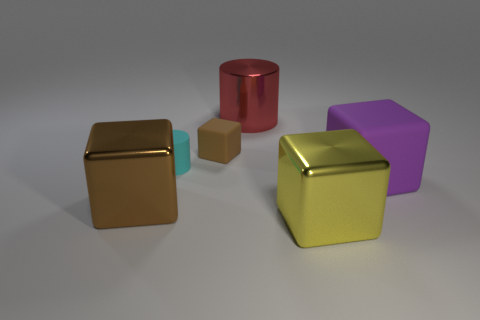Is there a metallic thing that has the same color as the small rubber block?
Give a very brief answer. Yes. There is a rubber cube behind the purple block; is its size the same as the yellow metal block?
Provide a succinct answer. No. What number of matte objects are either large yellow cubes or tiny gray objects?
Ensure brevity in your answer.  0. What material is the thing that is both to the right of the small cube and behind the large purple rubber object?
Keep it short and to the point. Metal. Does the large red cylinder have the same material as the purple block?
Offer a terse response. No. What is the size of the cube that is right of the tiny brown rubber block and in front of the purple rubber cube?
Provide a succinct answer. Large. What is the shape of the large matte object?
Make the answer very short. Cube. How many things are either small cubes or tiny brown rubber blocks that are behind the yellow cube?
Make the answer very short. 1. There is a big shiny cube that is left of the large yellow block; is it the same color as the small rubber block?
Provide a succinct answer. Yes. What color is the big thing that is in front of the red cylinder and behind the large brown object?
Your answer should be compact. Purple. 